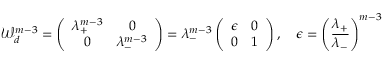Convert formula to latex. <formula><loc_0><loc_0><loc_500><loc_500>{ \mathcal { W } } _ { d } ^ { m - 3 } = \left ( \begin{array} { c c } { \lambda _ { + } ^ { m - 3 } } & { 0 } \\ { 0 } & { \lambda _ { - } ^ { m - 3 } } \end{array} \right ) = \lambda _ { - } ^ { m - 3 } \left ( \begin{array} { c c } { \epsilon } & { 0 } \\ { 0 } & { 1 } \end{array} \right ) , \quad \epsilon = \left ( \frac { \lambda _ { + } } { \lambda _ { - } } \right ) ^ { m - 3 }</formula> 